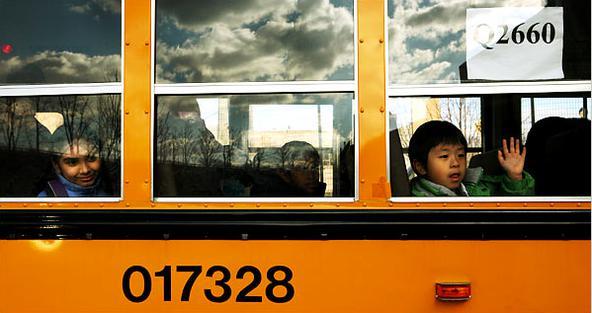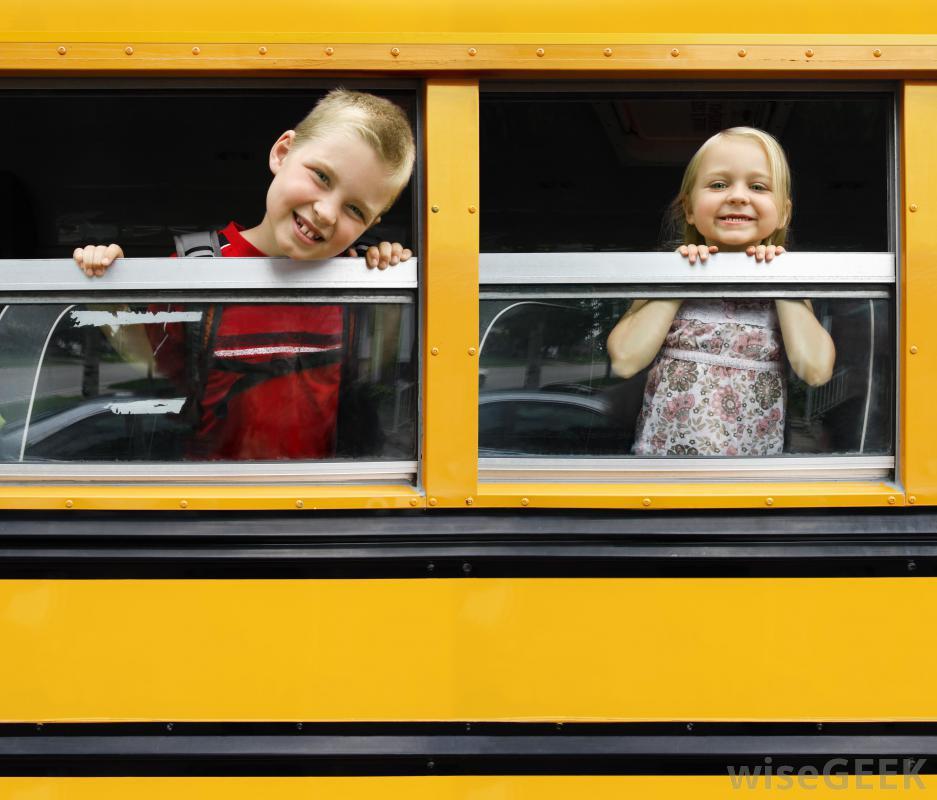The first image is the image on the left, the second image is the image on the right. Examine the images to the left and right. Is the description "In one of the images, there is a person standing outside of the bus." accurate? Answer yes or no. No. The first image is the image on the left, the second image is the image on the right. Given the left and right images, does the statement "In the right image, childrens' heads are peering out of the top half of open bus windows, and at least one hand is gripping a window ledge." hold true? Answer yes or no. Yes. 